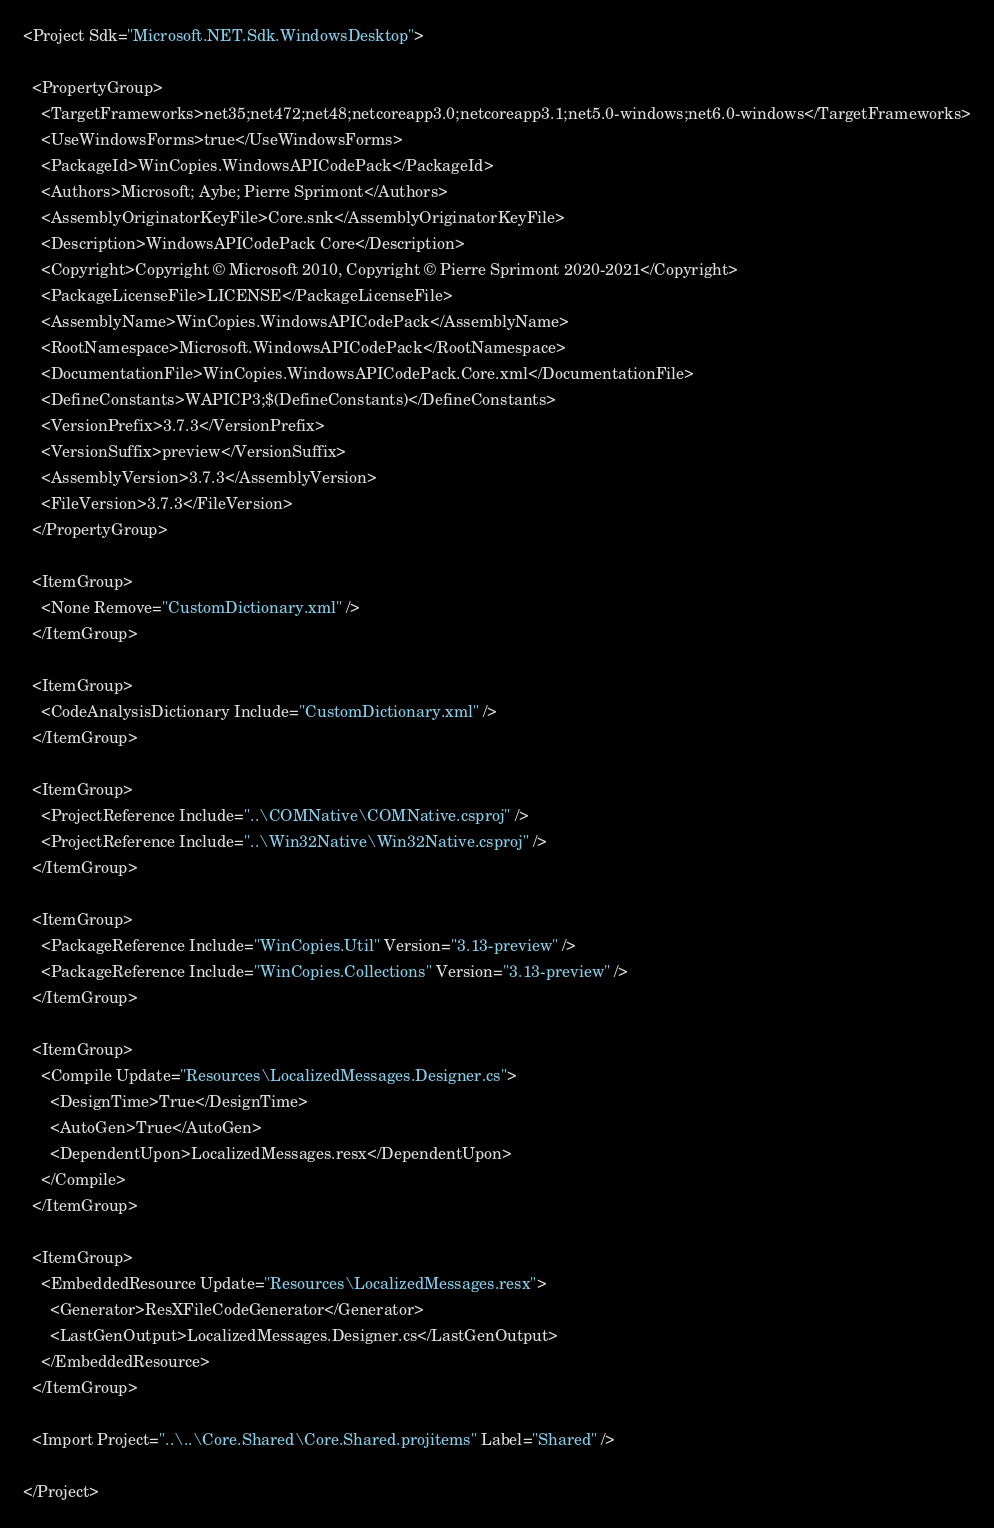<code> <loc_0><loc_0><loc_500><loc_500><_XML_><Project Sdk="Microsoft.NET.Sdk.WindowsDesktop">

  <PropertyGroup>
    <TargetFrameworks>net35;net472;net48;netcoreapp3.0;netcoreapp3.1;net5.0-windows;net6.0-windows</TargetFrameworks>
    <UseWindowsForms>true</UseWindowsForms>
    <PackageId>WinCopies.WindowsAPICodePack</PackageId>
    <Authors>Microsoft; Aybe; Pierre Sprimont</Authors>
    <AssemblyOriginatorKeyFile>Core.snk</AssemblyOriginatorKeyFile>
    <Description>WindowsAPICodePack Core</Description>
    <Copyright>Copyright © Microsoft 2010, Copyright © Pierre Sprimont 2020-2021</Copyright>
    <PackageLicenseFile>LICENSE</PackageLicenseFile>
    <AssemblyName>WinCopies.WindowsAPICodePack</AssemblyName>
    <RootNamespace>Microsoft.WindowsAPICodePack</RootNamespace>
    <DocumentationFile>WinCopies.WindowsAPICodePack.Core.xml</DocumentationFile>
    <DefineConstants>WAPICP3;$(DefineConstants)</DefineConstants>
    <VersionPrefix>3.7.3</VersionPrefix>
    <VersionSuffix>preview</VersionSuffix>
    <AssemblyVersion>3.7.3</AssemblyVersion>
    <FileVersion>3.7.3</FileVersion>
  </PropertyGroup>

  <ItemGroup>
    <None Remove="CustomDictionary.xml" />
  </ItemGroup>

  <ItemGroup>
    <CodeAnalysisDictionary Include="CustomDictionary.xml" />
  </ItemGroup>

  <ItemGroup>
    <ProjectReference Include="..\COMNative\COMNative.csproj" />
    <ProjectReference Include="..\Win32Native\Win32Native.csproj" />
  </ItemGroup>

  <ItemGroup>
    <PackageReference Include="WinCopies.Util" Version="3.13-preview" />
    <PackageReference Include="WinCopies.Collections" Version="3.13-preview" />
  </ItemGroup>

  <ItemGroup>
    <Compile Update="Resources\LocalizedMessages.Designer.cs">
      <DesignTime>True</DesignTime>
      <AutoGen>True</AutoGen>
      <DependentUpon>LocalizedMessages.resx</DependentUpon>
    </Compile>
  </ItemGroup>

  <ItemGroup>
    <EmbeddedResource Update="Resources\LocalizedMessages.resx">
      <Generator>ResXFileCodeGenerator</Generator>
      <LastGenOutput>LocalizedMessages.Designer.cs</LastGenOutput>
    </EmbeddedResource>
  </ItemGroup>

  <Import Project="..\..\Core.Shared\Core.Shared.projitems" Label="Shared" />

</Project>
</code> 